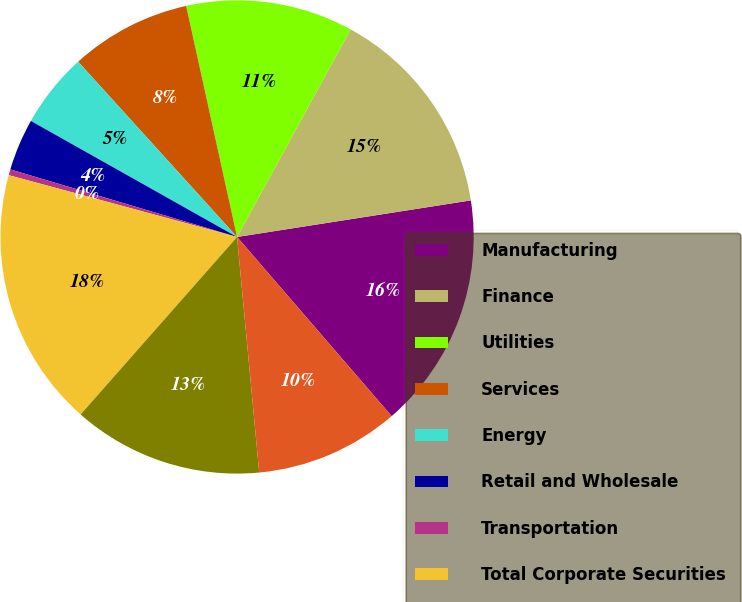Convert chart to OTSL. <chart><loc_0><loc_0><loc_500><loc_500><pie_chart><fcel>Manufacturing<fcel>Finance<fcel>Utilities<fcel>Services<fcel>Energy<fcel>Retail and Wholesale<fcel>Transportation<fcel>Total Corporate Securities<fcel>Asset-Backed Securities<fcel>US Government<nl><fcel>16.14%<fcel>14.56%<fcel>11.42%<fcel>8.27%<fcel>5.12%<fcel>3.55%<fcel>0.4%<fcel>17.71%<fcel>12.99%<fcel>9.84%<nl></chart> 